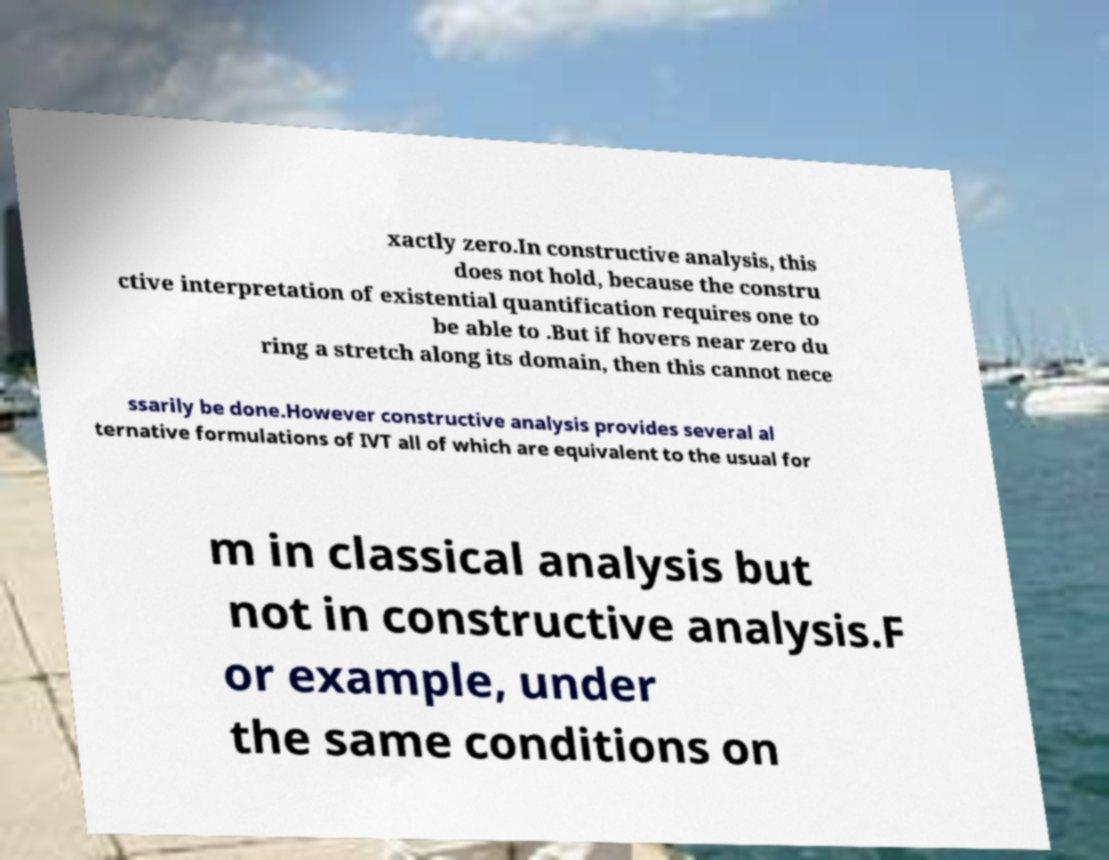Can you read and provide the text displayed in the image?This photo seems to have some interesting text. Can you extract and type it out for me? xactly zero.In constructive analysis, this does not hold, because the constru ctive interpretation of existential quantification requires one to be able to .But if hovers near zero du ring a stretch along its domain, then this cannot nece ssarily be done.However constructive analysis provides several al ternative formulations of IVT all of which are equivalent to the usual for m in classical analysis but not in constructive analysis.F or example, under the same conditions on 